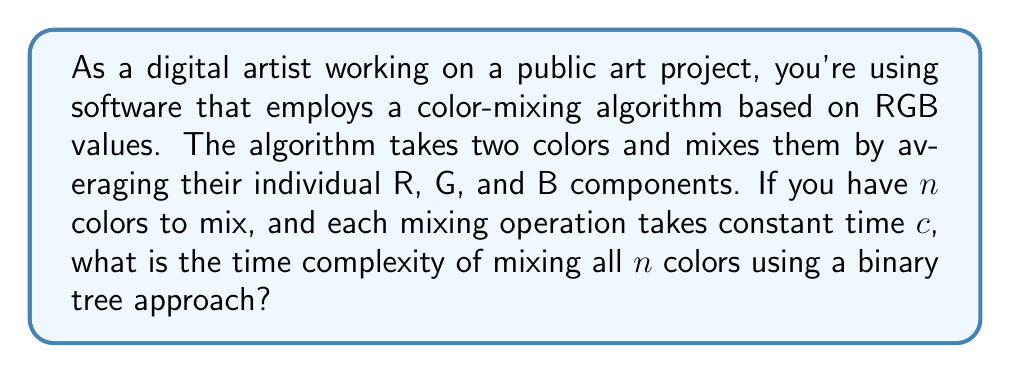Could you help me with this problem? Let's approach this step-by-step:

1) In a binary tree approach, we start by pairing up the $n$ colors and mixing each pair. This reduces the number of colors to $\frac{n}{2}$ in the first step.

2) We repeat this process, each time halving the number of colors until we're left with just one final color.

3) The number of levels in this binary tree will be $\log_2(n)$, as we're halving the number of colors at each level.

4) At each level, we're performing $\frac{n}{2^i}$ mixing operations, where $i$ is the level number (starting from 0).

5) The total number of operations will be the sum of operations at each level:

   $$\sum_{i=0}^{\log_2(n)-1} \frac{n}{2^i}$$

6) This sum can be simplified to:

   $$n \sum_{i=0}^{\log_2(n)-1} \frac{1}{2^i} = n(2 - \frac{2}{n}) = 2n - 2$$

7) Since each operation takes constant time $c$, the total time will be $c(2n - 2)$.

8) In big O notation, we ignore constants, so the time complexity is $O(n)$.

This linear time complexity is efficient compared to a naive approach of mixing colors one by one, which would take $O(n^2)$ time.
Answer: The time complexity of mixing $n$ colors using a binary tree approach is $O(n)$. 